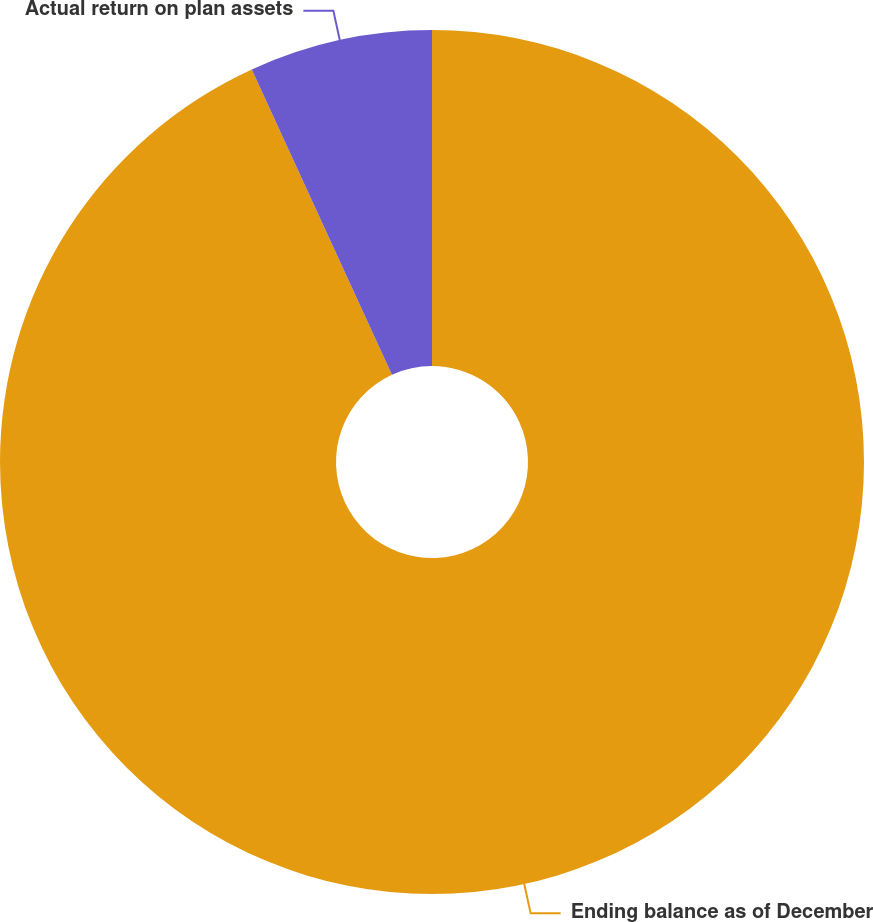<chart> <loc_0><loc_0><loc_500><loc_500><pie_chart><fcel>Ending balance as of December<fcel>Actual return on plan assets<nl><fcel>93.15%<fcel>6.85%<nl></chart> 